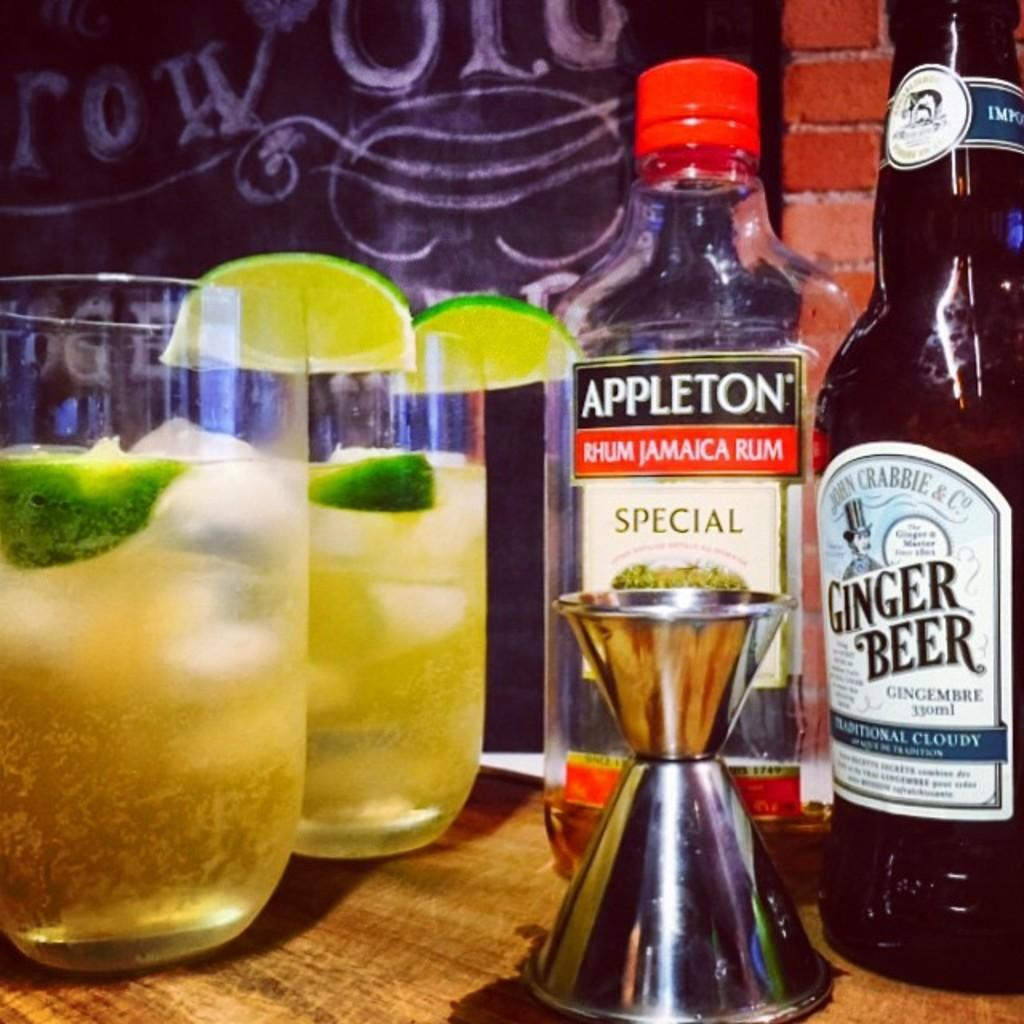Provide a one-sentence caption for the provided image. A bottle of jamaican rum and ginger beer next to two other cups. 